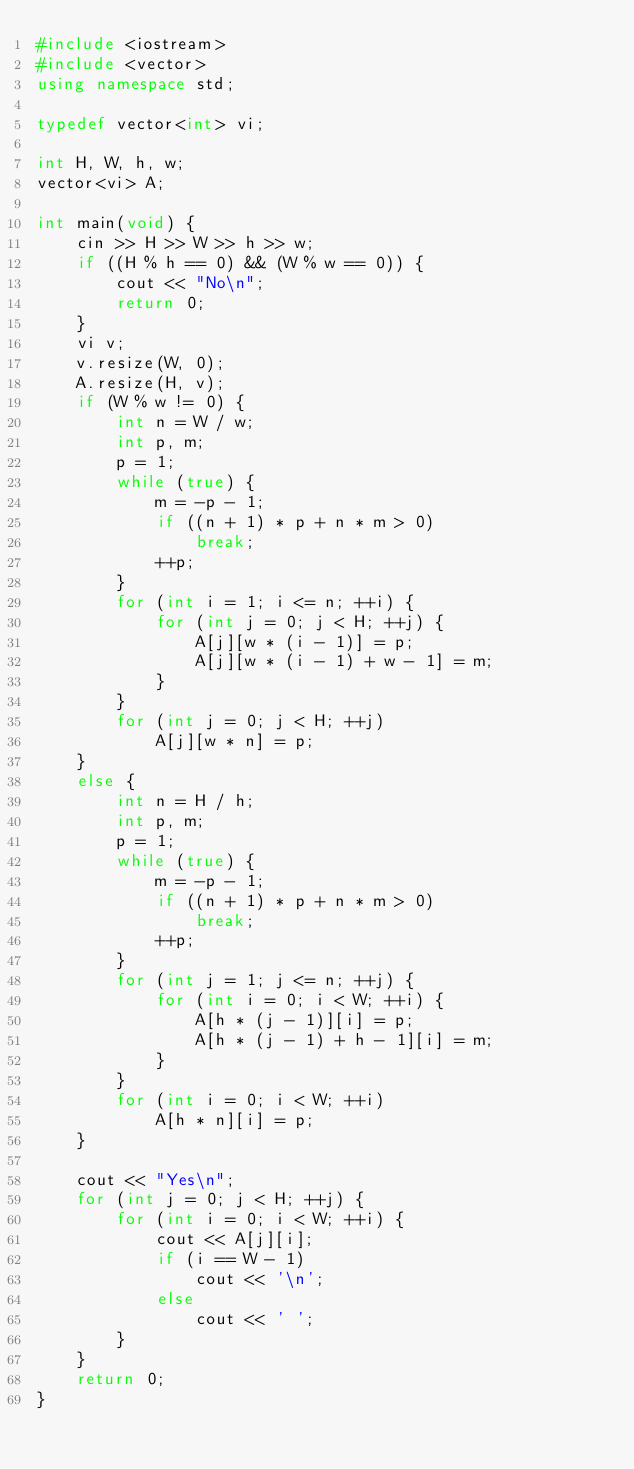<code> <loc_0><loc_0><loc_500><loc_500><_C++_>#include <iostream>
#include <vector>
using namespace std;

typedef vector<int> vi;

int H, W, h, w;
vector<vi> A;

int main(void) {
	cin >> H >> W >> h >> w;
	if ((H % h == 0) && (W % w == 0)) {
		cout << "No\n";
		return 0;
	}
	vi v;
	v.resize(W, 0);
	A.resize(H, v);
	if (W % w != 0) {
		int n = W / w;
		int p, m;
		p = 1;
		while (true) {
			m = -p - 1;
			if ((n + 1) * p + n * m > 0)
				break;
			++p;
		}
		for (int i = 1; i <= n; ++i) {
			for (int j = 0; j < H; ++j) {
				A[j][w * (i - 1)] = p;
				A[j][w * (i - 1) + w - 1] = m;
			}
		}
		for (int j = 0; j < H; ++j)
			A[j][w * n] = p;
	}
	else {
		int n = H / h;
		int p, m;
		p = 1;
		while (true) {
			m = -p - 1;
			if ((n + 1) * p + n * m > 0)
				break;
			++p;
		}
		for (int j = 1; j <= n; ++j) {
			for (int i = 0; i < W; ++i) {
				A[h * (j - 1)][i] = p;
				A[h * (j - 1) + h - 1][i] = m;
			}
		}
		for (int i = 0; i < W; ++i)
			A[h * n][i] = p;
	}

	cout << "Yes\n";
	for (int j = 0; j < H; ++j) {
		for (int i = 0; i < W; ++i) {
			cout << A[j][i];
			if (i == W - 1)
				cout << '\n';
			else
				cout << ' ';
		}
	}
	return 0;
}
</code> 